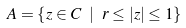Convert formula to latex. <formula><loc_0><loc_0><loc_500><loc_500>A = \left \{ z \in { C } \ | \ r \leq | z | \leq 1 \right \}</formula> 